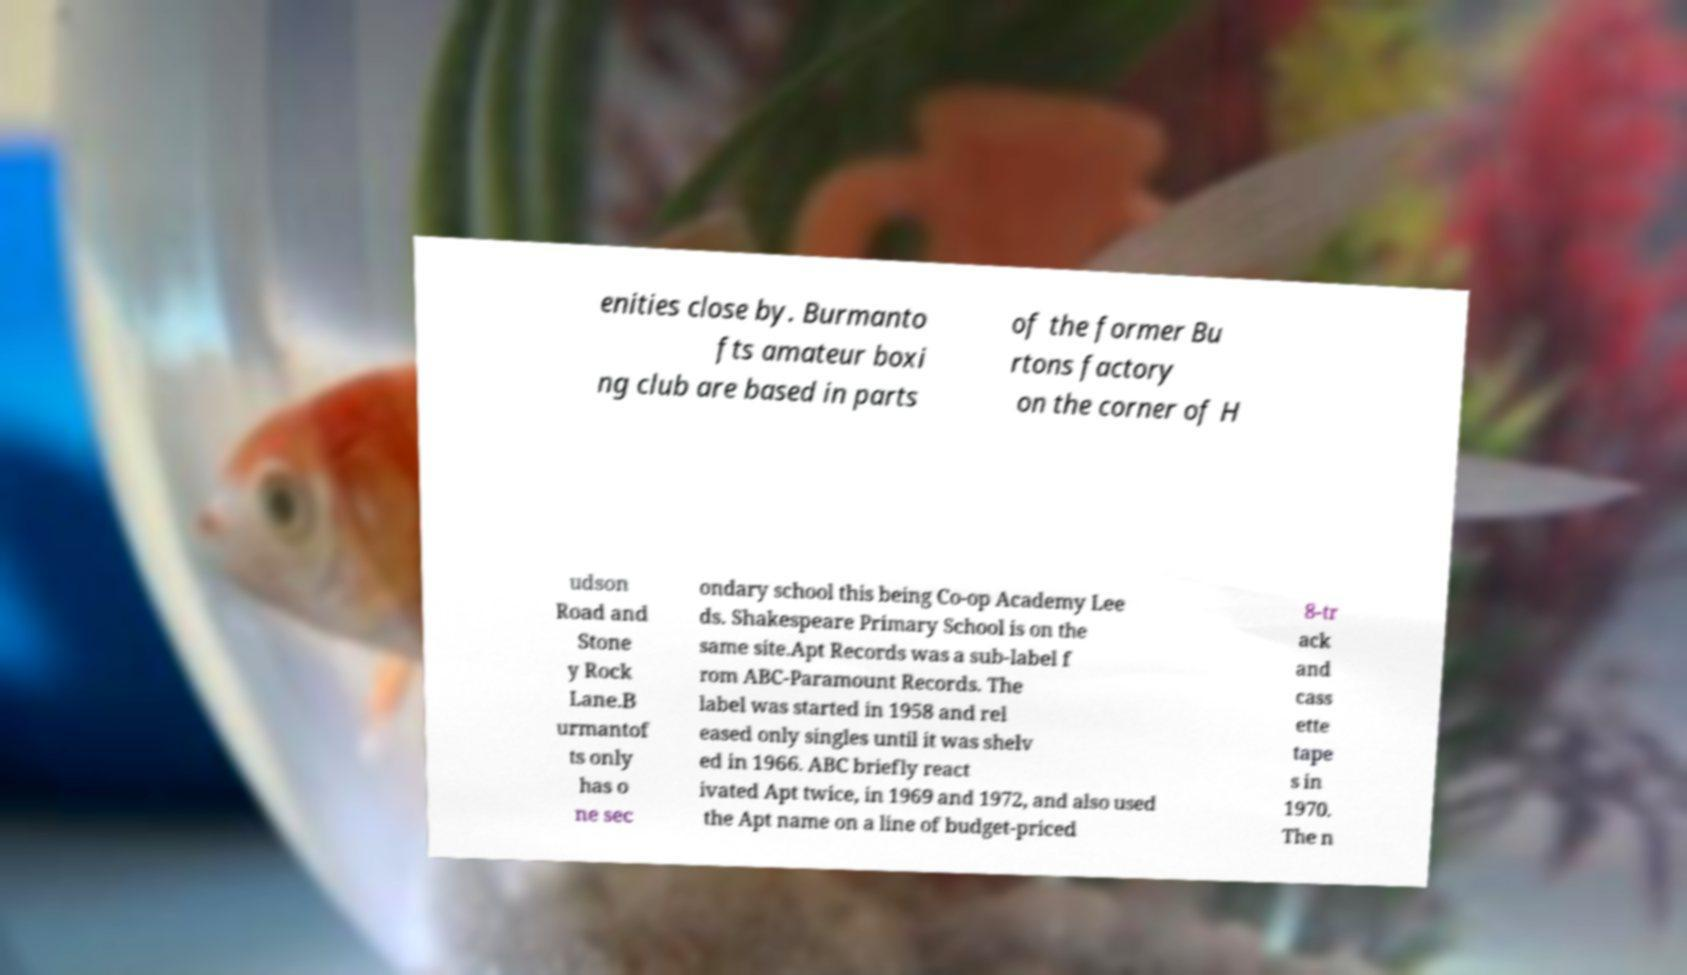Can you accurately transcribe the text from the provided image for me? enities close by. Burmanto fts amateur boxi ng club are based in parts of the former Bu rtons factory on the corner of H udson Road and Stone y Rock Lane.B urmantof ts only has o ne sec ondary school this being Co-op Academy Lee ds. Shakespeare Primary School is on the same site.Apt Records was a sub-label f rom ABC-Paramount Records. The label was started in 1958 and rel eased only singles until it was shelv ed in 1966. ABC briefly react ivated Apt twice, in 1969 and 1972, and also used the Apt name on a line of budget-priced 8-tr ack and cass ette tape s in 1970. The n 